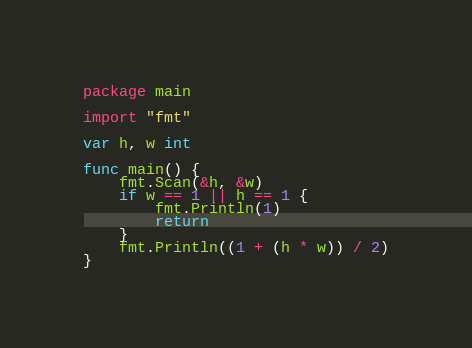Convert code to text. <code><loc_0><loc_0><loc_500><loc_500><_Go_>package main

import "fmt"

var h, w int

func main() {
	fmt.Scan(&h, &w)
	if w == 1 || h == 1 {
		fmt.Println(1)
		return
	}
	fmt.Println((1 + (h * w)) / 2)
}
</code> 